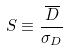Convert formula to latex. <formula><loc_0><loc_0><loc_500><loc_500>S \equiv \frac { \overline { D } } { \sigma _ { D } }</formula> 